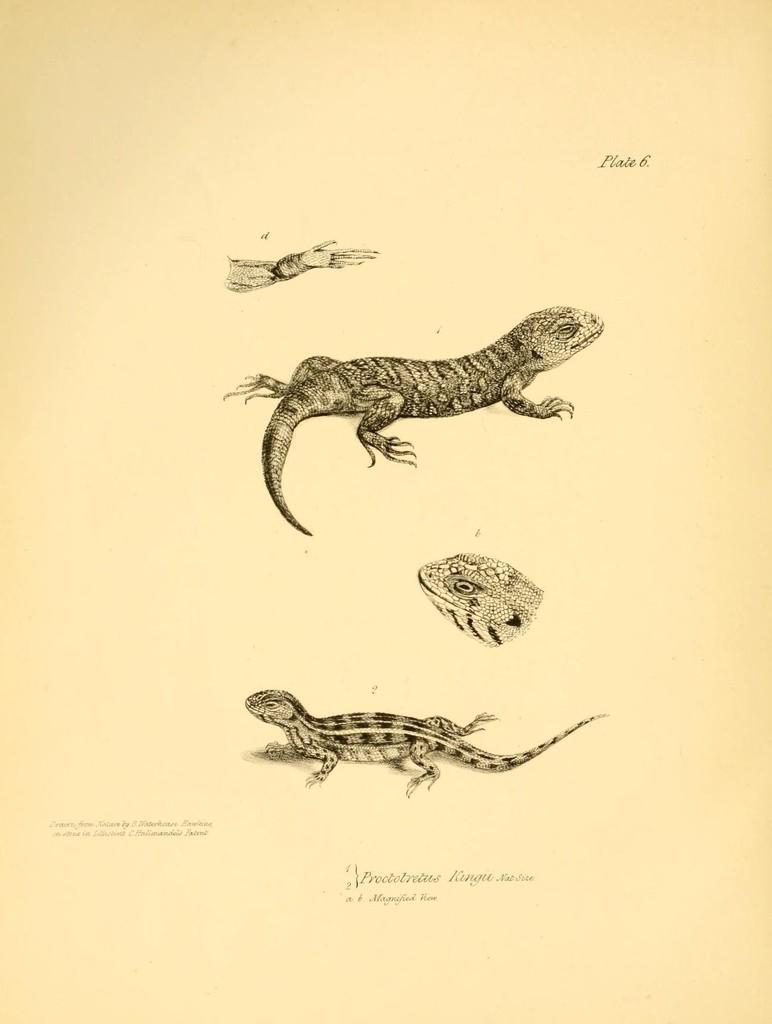What is the main subject of the image? There is a picture of a lizard in the image. Where is the picture of the lizard located in the image? The picture of the lizard is in the middle of the image. What else can be seen at the bottom of the image? There is text written at the bottom of the image. How many rings are visible on the lizard's tail in the image? There are no rings visible on the lizard's tail in the image, as the image only shows a picture of a lizard with no additional details about its tail. 